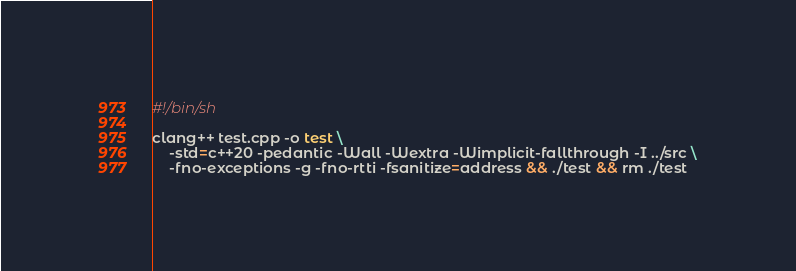Convert code to text. <code><loc_0><loc_0><loc_500><loc_500><_Bash_>#!/bin/sh

clang++ test.cpp -o test \
	-std=c++20 -pedantic -Wall -Wextra -Wimplicit-fallthrough -I ../src \
	-fno-exceptions -g -fno-rtti -fsanitize=address && ./test && rm ./test
</code> 